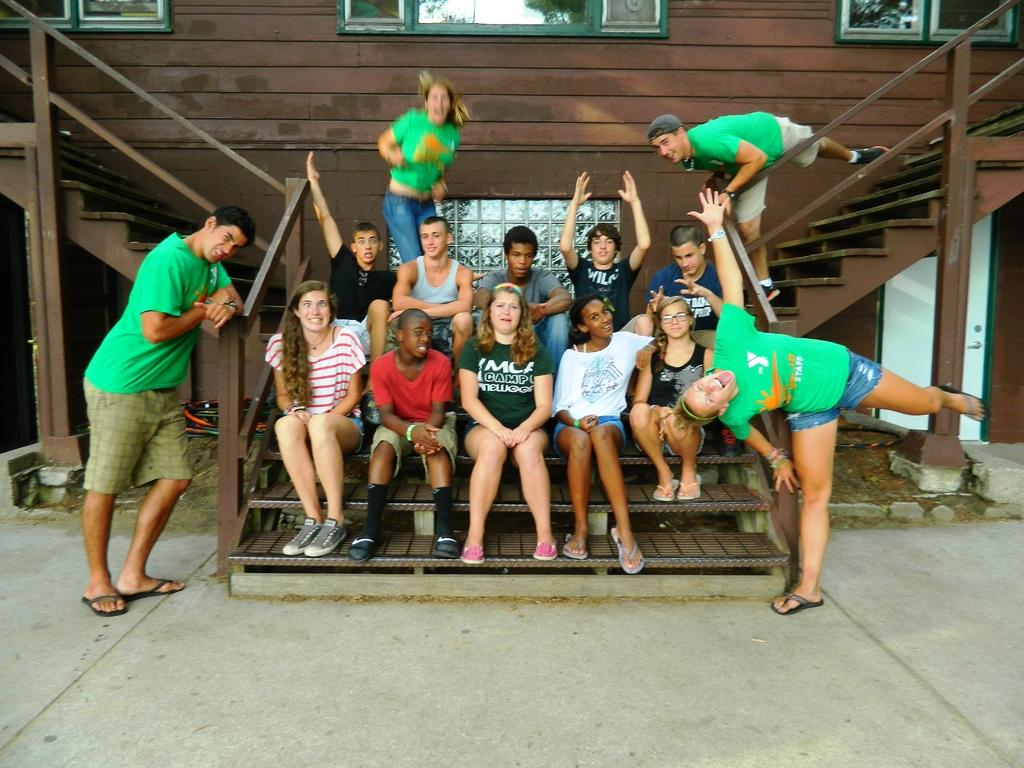How many people are standing in the image? There are two people standing on the ground in the image. What are some people doing in the image? Some people are sitting on the steps in the image. What can be seen in the background of the image? There is a wall, a door, windows, and some objects in the background. What type of plantation can be seen in the background of the image? There is no plantation present in the background of the image. What type of hospital is visible in the image? There is no hospital visible in the image. 